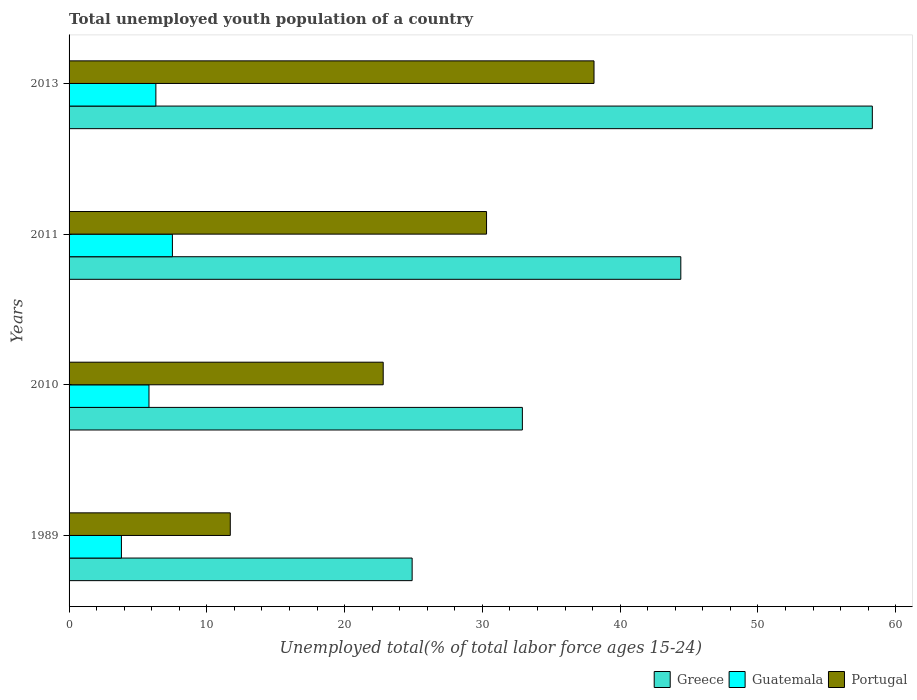Are the number of bars on each tick of the Y-axis equal?
Your answer should be compact. Yes. How many bars are there on the 4th tick from the top?
Give a very brief answer. 3. How many bars are there on the 3rd tick from the bottom?
Offer a terse response. 3. In how many cases, is the number of bars for a given year not equal to the number of legend labels?
Make the answer very short. 0. What is the percentage of total unemployed youth population of a country in Portugal in 2010?
Provide a succinct answer. 22.8. Across all years, what is the maximum percentage of total unemployed youth population of a country in Greece?
Provide a succinct answer. 58.3. Across all years, what is the minimum percentage of total unemployed youth population of a country in Portugal?
Make the answer very short. 11.7. In which year was the percentage of total unemployed youth population of a country in Guatemala minimum?
Your response must be concise. 1989. What is the total percentage of total unemployed youth population of a country in Guatemala in the graph?
Ensure brevity in your answer.  23.4. What is the difference between the percentage of total unemployed youth population of a country in Guatemala in 1989 and that in 2011?
Offer a very short reply. -3.7. What is the difference between the percentage of total unemployed youth population of a country in Greece in 2011 and the percentage of total unemployed youth population of a country in Guatemala in 2013?
Offer a very short reply. 38.1. What is the average percentage of total unemployed youth population of a country in Guatemala per year?
Make the answer very short. 5.85. In the year 2013, what is the difference between the percentage of total unemployed youth population of a country in Guatemala and percentage of total unemployed youth population of a country in Greece?
Give a very brief answer. -52. What is the ratio of the percentage of total unemployed youth population of a country in Guatemala in 1989 to that in 2013?
Offer a terse response. 0.6. Is the percentage of total unemployed youth population of a country in Guatemala in 1989 less than that in 2011?
Provide a succinct answer. Yes. Is the difference between the percentage of total unemployed youth population of a country in Guatemala in 2011 and 2013 greater than the difference between the percentage of total unemployed youth population of a country in Greece in 2011 and 2013?
Your answer should be compact. Yes. What is the difference between the highest and the second highest percentage of total unemployed youth population of a country in Portugal?
Offer a terse response. 7.8. What is the difference between the highest and the lowest percentage of total unemployed youth population of a country in Guatemala?
Make the answer very short. 3.7. Is the sum of the percentage of total unemployed youth population of a country in Greece in 2010 and 2011 greater than the maximum percentage of total unemployed youth population of a country in Guatemala across all years?
Offer a very short reply. Yes. What does the 3rd bar from the top in 1989 represents?
Your answer should be very brief. Greece. What does the 1st bar from the bottom in 2013 represents?
Your answer should be compact. Greece. How many bars are there?
Your answer should be compact. 12. Are all the bars in the graph horizontal?
Give a very brief answer. Yes. What is the difference between two consecutive major ticks on the X-axis?
Offer a very short reply. 10. Does the graph contain any zero values?
Provide a succinct answer. No. Does the graph contain grids?
Offer a terse response. No. Where does the legend appear in the graph?
Offer a very short reply. Bottom right. What is the title of the graph?
Offer a very short reply. Total unemployed youth population of a country. What is the label or title of the X-axis?
Your answer should be compact. Unemployed total(% of total labor force ages 15-24). What is the Unemployed total(% of total labor force ages 15-24) of Greece in 1989?
Ensure brevity in your answer.  24.9. What is the Unemployed total(% of total labor force ages 15-24) of Guatemala in 1989?
Keep it short and to the point. 3.8. What is the Unemployed total(% of total labor force ages 15-24) of Portugal in 1989?
Provide a succinct answer. 11.7. What is the Unemployed total(% of total labor force ages 15-24) in Greece in 2010?
Offer a very short reply. 32.9. What is the Unemployed total(% of total labor force ages 15-24) in Guatemala in 2010?
Offer a very short reply. 5.8. What is the Unemployed total(% of total labor force ages 15-24) in Portugal in 2010?
Keep it short and to the point. 22.8. What is the Unemployed total(% of total labor force ages 15-24) of Greece in 2011?
Offer a very short reply. 44.4. What is the Unemployed total(% of total labor force ages 15-24) of Guatemala in 2011?
Ensure brevity in your answer.  7.5. What is the Unemployed total(% of total labor force ages 15-24) of Portugal in 2011?
Provide a succinct answer. 30.3. What is the Unemployed total(% of total labor force ages 15-24) of Greece in 2013?
Give a very brief answer. 58.3. What is the Unemployed total(% of total labor force ages 15-24) in Guatemala in 2013?
Provide a short and direct response. 6.3. What is the Unemployed total(% of total labor force ages 15-24) in Portugal in 2013?
Give a very brief answer. 38.1. Across all years, what is the maximum Unemployed total(% of total labor force ages 15-24) in Greece?
Keep it short and to the point. 58.3. Across all years, what is the maximum Unemployed total(% of total labor force ages 15-24) in Portugal?
Give a very brief answer. 38.1. Across all years, what is the minimum Unemployed total(% of total labor force ages 15-24) of Greece?
Ensure brevity in your answer.  24.9. Across all years, what is the minimum Unemployed total(% of total labor force ages 15-24) in Guatemala?
Your answer should be compact. 3.8. Across all years, what is the minimum Unemployed total(% of total labor force ages 15-24) in Portugal?
Your answer should be compact. 11.7. What is the total Unemployed total(% of total labor force ages 15-24) of Greece in the graph?
Ensure brevity in your answer.  160.5. What is the total Unemployed total(% of total labor force ages 15-24) in Guatemala in the graph?
Provide a short and direct response. 23.4. What is the total Unemployed total(% of total labor force ages 15-24) in Portugal in the graph?
Provide a short and direct response. 102.9. What is the difference between the Unemployed total(% of total labor force ages 15-24) of Greece in 1989 and that in 2011?
Keep it short and to the point. -19.5. What is the difference between the Unemployed total(% of total labor force ages 15-24) of Guatemala in 1989 and that in 2011?
Offer a very short reply. -3.7. What is the difference between the Unemployed total(% of total labor force ages 15-24) of Portugal in 1989 and that in 2011?
Your answer should be very brief. -18.6. What is the difference between the Unemployed total(% of total labor force ages 15-24) in Greece in 1989 and that in 2013?
Your answer should be compact. -33.4. What is the difference between the Unemployed total(% of total labor force ages 15-24) in Guatemala in 1989 and that in 2013?
Provide a short and direct response. -2.5. What is the difference between the Unemployed total(% of total labor force ages 15-24) of Portugal in 1989 and that in 2013?
Your response must be concise. -26.4. What is the difference between the Unemployed total(% of total labor force ages 15-24) in Greece in 2010 and that in 2013?
Make the answer very short. -25.4. What is the difference between the Unemployed total(% of total labor force ages 15-24) of Portugal in 2010 and that in 2013?
Offer a very short reply. -15.3. What is the difference between the Unemployed total(% of total labor force ages 15-24) in Greece in 1989 and the Unemployed total(% of total labor force ages 15-24) in Guatemala in 2010?
Your response must be concise. 19.1. What is the difference between the Unemployed total(% of total labor force ages 15-24) in Guatemala in 1989 and the Unemployed total(% of total labor force ages 15-24) in Portugal in 2010?
Keep it short and to the point. -19. What is the difference between the Unemployed total(% of total labor force ages 15-24) of Greece in 1989 and the Unemployed total(% of total labor force ages 15-24) of Guatemala in 2011?
Your response must be concise. 17.4. What is the difference between the Unemployed total(% of total labor force ages 15-24) of Greece in 1989 and the Unemployed total(% of total labor force ages 15-24) of Portugal in 2011?
Your response must be concise. -5.4. What is the difference between the Unemployed total(% of total labor force ages 15-24) in Guatemala in 1989 and the Unemployed total(% of total labor force ages 15-24) in Portugal in 2011?
Make the answer very short. -26.5. What is the difference between the Unemployed total(% of total labor force ages 15-24) of Guatemala in 1989 and the Unemployed total(% of total labor force ages 15-24) of Portugal in 2013?
Provide a short and direct response. -34.3. What is the difference between the Unemployed total(% of total labor force ages 15-24) of Greece in 2010 and the Unemployed total(% of total labor force ages 15-24) of Guatemala in 2011?
Ensure brevity in your answer.  25.4. What is the difference between the Unemployed total(% of total labor force ages 15-24) of Greece in 2010 and the Unemployed total(% of total labor force ages 15-24) of Portugal in 2011?
Provide a short and direct response. 2.6. What is the difference between the Unemployed total(% of total labor force ages 15-24) of Guatemala in 2010 and the Unemployed total(% of total labor force ages 15-24) of Portugal in 2011?
Provide a short and direct response. -24.5. What is the difference between the Unemployed total(% of total labor force ages 15-24) in Greece in 2010 and the Unemployed total(% of total labor force ages 15-24) in Guatemala in 2013?
Ensure brevity in your answer.  26.6. What is the difference between the Unemployed total(% of total labor force ages 15-24) in Guatemala in 2010 and the Unemployed total(% of total labor force ages 15-24) in Portugal in 2013?
Your response must be concise. -32.3. What is the difference between the Unemployed total(% of total labor force ages 15-24) in Greece in 2011 and the Unemployed total(% of total labor force ages 15-24) in Guatemala in 2013?
Keep it short and to the point. 38.1. What is the difference between the Unemployed total(% of total labor force ages 15-24) of Guatemala in 2011 and the Unemployed total(% of total labor force ages 15-24) of Portugal in 2013?
Your answer should be compact. -30.6. What is the average Unemployed total(% of total labor force ages 15-24) of Greece per year?
Provide a succinct answer. 40.12. What is the average Unemployed total(% of total labor force ages 15-24) in Guatemala per year?
Offer a very short reply. 5.85. What is the average Unemployed total(% of total labor force ages 15-24) in Portugal per year?
Make the answer very short. 25.73. In the year 1989, what is the difference between the Unemployed total(% of total labor force ages 15-24) of Greece and Unemployed total(% of total labor force ages 15-24) of Guatemala?
Offer a very short reply. 21.1. In the year 1989, what is the difference between the Unemployed total(% of total labor force ages 15-24) in Greece and Unemployed total(% of total labor force ages 15-24) in Portugal?
Keep it short and to the point. 13.2. In the year 2010, what is the difference between the Unemployed total(% of total labor force ages 15-24) in Greece and Unemployed total(% of total labor force ages 15-24) in Guatemala?
Ensure brevity in your answer.  27.1. In the year 2011, what is the difference between the Unemployed total(% of total labor force ages 15-24) of Greece and Unemployed total(% of total labor force ages 15-24) of Guatemala?
Your answer should be very brief. 36.9. In the year 2011, what is the difference between the Unemployed total(% of total labor force ages 15-24) of Greece and Unemployed total(% of total labor force ages 15-24) of Portugal?
Give a very brief answer. 14.1. In the year 2011, what is the difference between the Unemployed total(% of total labor force ages 15-24) of Guatemala and Unemployed total(% of total labor force ages 15-24) of Portugal?
Provide a succinct answer. -22.8. In the year 2013, what is the difference between the Unemployed total(% of total labor force ages 15-24) of Greece and Unemployed total(% of total labor force ages 15-24) of Guatemala?
Your response must be concise. 52. In the year 2013, what is the difference between the Unemployed total(% of total labor force ages 15-24) of Greece and Unemployed total(% of total labor force ages 15-24) of Portugal?
Your answer should be compact. 20.2. In the year 2013, what is the difference between the Unemployed total(% of total labor force ages 15-24) of Guatemala and Unemployed total(% of total labor force ages 15-24) of Portugal?
Offer a very short reply. -31.8. What is the ratio of the Unemployed total(% of total labor force ages 15-24) of Greece in 1989 to that in 2010?
Give a very brief answer. 0.76. What is the ratio of the Unemployed total(% of total labor force ages 15-24) in Guatemala in 1989 to that in 2010?
Your response must be concise. 0.66. What is the ratio of the Unemployed total(% of total labor force ages 15-24) in Portugal in 1989 to that in 2010?
Provide a succinct answer. 0.51. What is the ratio of the Unemployed total(% of total labor force ages 15-24) in Greece in 1989 to that in 2011?
Ensure brevity in your answer.  0.56. What is the ratio of the Unemployed total(% of total labor force ages 15-24) in Guatemala in 1989 to that in 2011?
Your answer should be compact. 0.51. What is the ratio of the Unemployed total(% of total labor force ages 15-24) of Portugal in 1989 to that in 2011?
Keep it short and to the point. 0.39. What is the ratio of the Unemployed total(% of total labor force ages 15-24) in Greece in 1989 to that in 2013?
Keep it short and to the point. 0.43. What is the ratio of the Unemployed total(% of total labor force ages 15-24) in Guatemala in 1989 to that in 2013?
Ensure brevity in your answer.  0.6. What is the ratio of the Unemployed total(% of total labor force ages 15-24) of Portugal in 1989 to that in 2013?
Your answer should be compact. 0.31. What is the ratio of the Unemployed total(% of total labor force ages 15-24) of Greece in 2010 to that in 2011?
Provide a short and direct response. 0.74. What is the ratio of the Unemployed total(% of total labor force ages 15-24) in Guatemala in 2010 to that in 2011?
Make the answer very short. 0.77. What is the ratio of the Unemployed total(% of total labor force ages 15-24) in Portugal in 2010 to that in 2011?
Ensure brevity in your answer.  0.75. What is the ratio of the Unemployed total(% of total labor force ages 15-24) of Greece in 2010 to that in 2013?
Your answer should be very brief. 0.56. What is the ratio of the Unemployed total(% of total labor force ages 15-24) of Guatemala in 2010 to that in 2013?
Your response must be concise. 0.92. What is the ratio of the Unemployed total(% of total labor force ages 15-24) of Portugal in 2010 to that in 2013?
Your response must be concise. 0.6. What is the ratio of the Unemployed total(% of total labor force ages 15-24) of Greece in 2011 to that in 2013?
Provide a short and direct response. 0.76. What is the ratio of the Unemployed total(% of total labor force ages 15-24) in Guatemala in 2011 to that in 2013?
Provide a succinct answer. 1.19. What is the ratio of the Unemployed total(% of total labor force ages 15-24) in Portugal in 2011 to that in 2013?
Offer a terse response. 0.8. What is the difference between the highest and the second highest Unemployed total(% of total labor force ages 15-24) in Guatemala?
Offer a terse response. 1.2. What is the difference between the highest and the second highest Unemployed total(% of total labor force ages 15-24) of Portugal?
Keep it short and to the point. 7.8. What is the difference between the highest and the lowest Unemployed total(% of total labor force ages 15-24) in Greece?
Your answer should be compact. 33.4. What is the difference between the highest and the lowest Unemployed total(% of total labor force ages 15-24) in Portugal?
Make the answer very short. 26.4. 